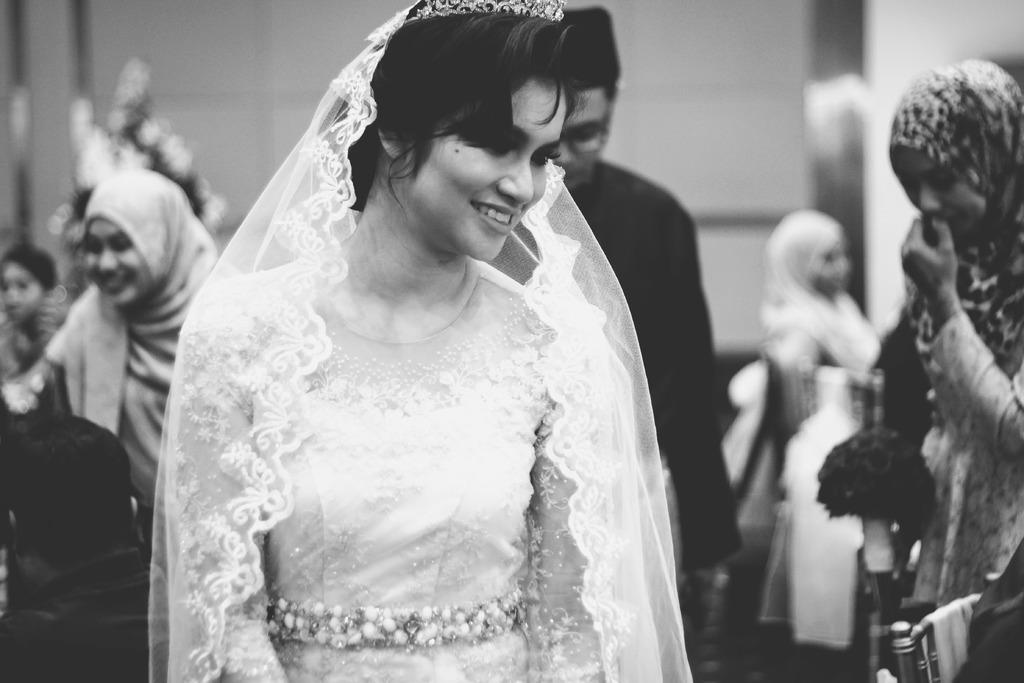What is the color scheme of the image? The image is black and white. Can you describe the woman in the image? There is a woman with a veil in the image. Are there any other people visible in the image? Yes, there are people behind the woman. How would you describe the background of the image? The background is blurred. Where is the nest located in the image? There is no nest present in the image. What type of patch can be seen on the woman's clothing in the image? The image is black and white, so it is not possible to determine the type of patch on the woman's clothing. 